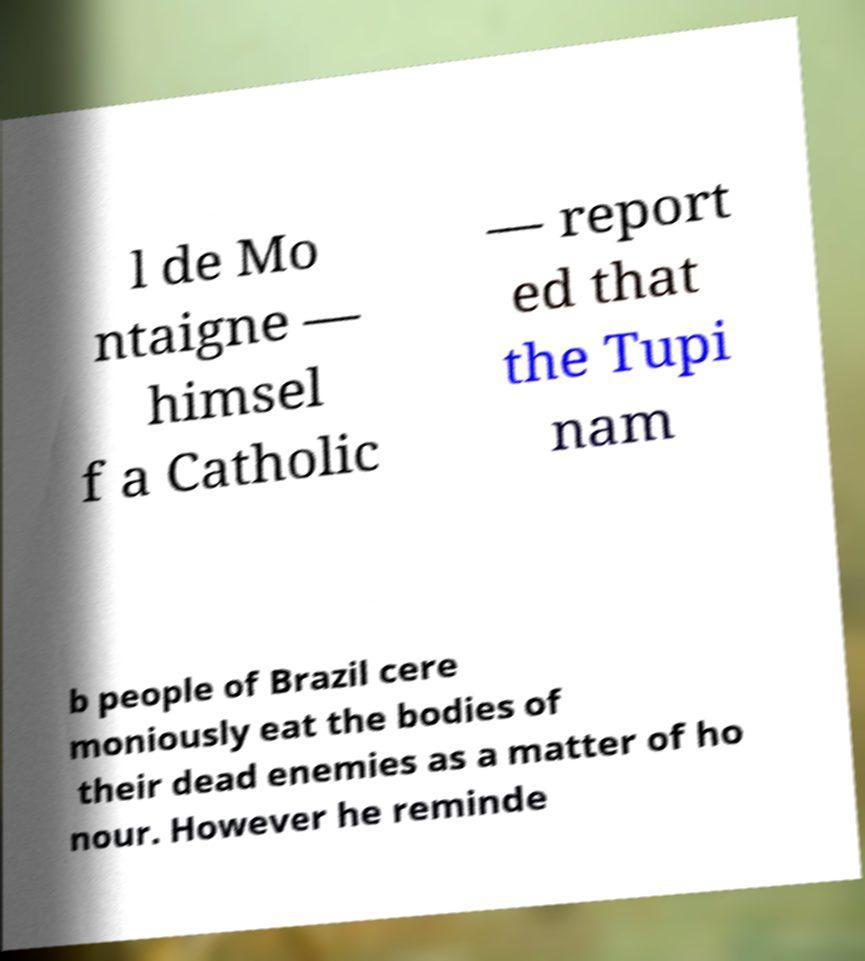I need the written content from this picture converted into text. Can you do that? l de Mo ntaigne — himsel f a Catholic — report ed that the Tupi nam b people of Brazil cere moniously eat the bodies of their dead enemies as a matter of ho nour. However he reminde 